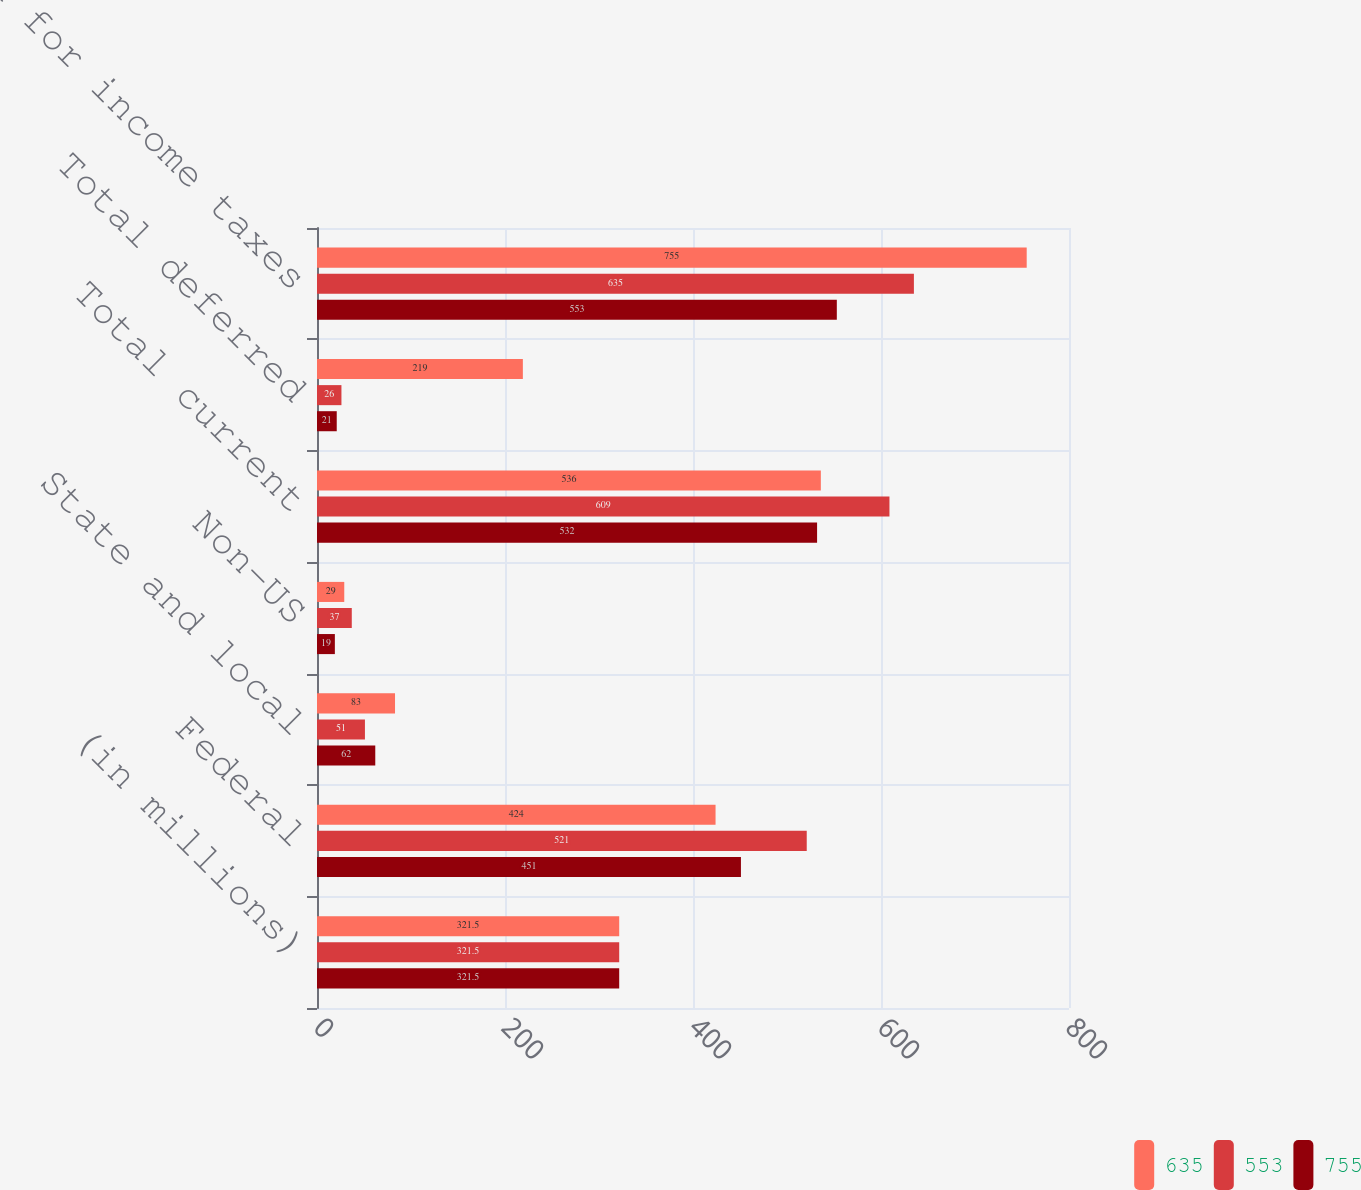Convert chart. <chart><loc_0><loc_0><loc_500><loc_500><stacked_bar_chart><ecel><fcel>(in millions)<fcel>Federal<fcel>State and local<fcel>Non-US<fcel>Total current<fcel>Total deferred<fcel>Provision for income taxes<nl><fcel>635<fcel>321.5<fcel>424<fcel>83<fcel>29<fcel>536<fcel>219<fcel>755<nl><fcel>553<fcel>321.5<fcel>521<fcel>51<fcel>37<fcel>609<fcel>26<fcel>635<nl><fcel>755<fcel>321.5<fcel>451<fcel>62<fcel>19<fcel>532<fcel>21<fcel>553<nl></chart> 